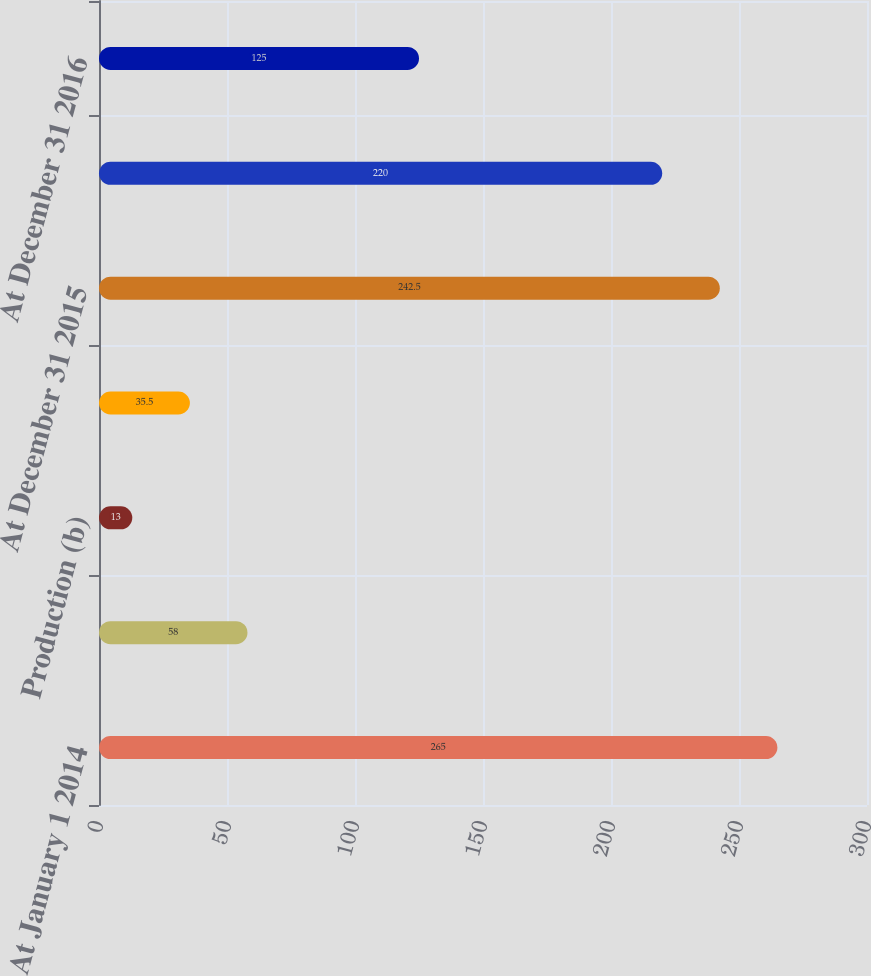Convert chart. <chart><loc_0><loc_0><loc_500><loc_500><bar_chart><fcel>At January 1 2014<fcel>Revisions of previous<fcel>Production (b)<fcel>At December 31 2014 Revisions<fcel>At December 31 2015<fcel>At December 31 2016 (c)<fcel>At December 31 2016<nl><fcel>265<fcel>58<fcel>13<fcel>35.5<fcel>242.5<fcel>220<fcel>125<nl></chart> 